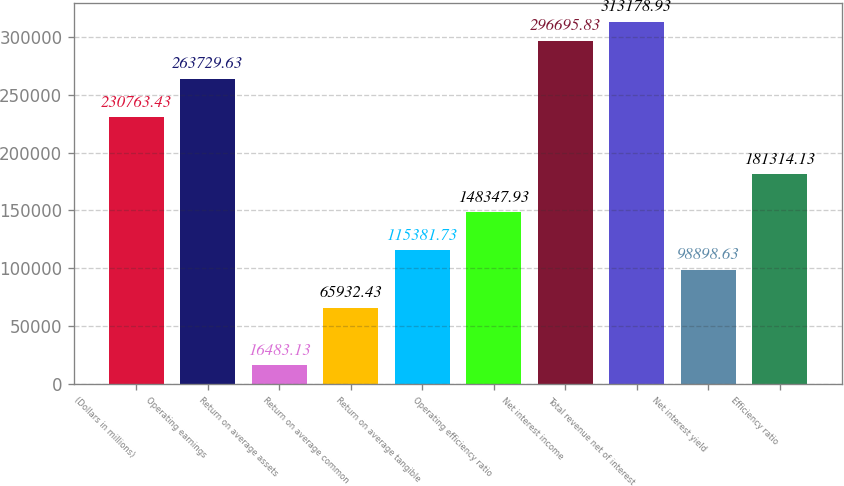Convert chart to OTSL. <chart><loc_0><loc_0><loc_500><loc_500><bar_chart><fcel>(Dollars in millions)<fcel>Operating earnings<fcel>Return on average assets<fcel>Return on average common<fcel>Return on average tangible<fcel>Operating efficiency ratio<fcel>Net interest income<fcel>Total revenue net of interest<fcel>Net interest yield<fcel>Efficiency ratio<nl><fcel>230763<fcel>263730<fcel>16483.1<fcel>65932.4<fcel>115382<fcel>148348<fcel>296696<fcel>313179<fcel>98898.6<fcel>181314<nl></chart> 